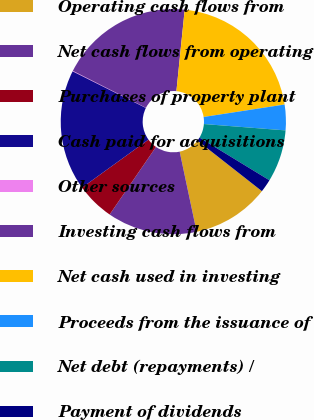Convert chart to OTSL. <chart><loc_0><loc_0><loc_500><loc_500><pie_chart><fcel>Operating cash flows from<fcel>Net cash flows from operating<fcel>Purchases of property plant<fcel>Cash paid for acquisitions<fcel>Other sources<fcel>Investing cash flows from<fcel>Net cash used in investing<fcel>Proceeds from the issuance of<fcel>Net debt (repayments) /<fcel>Payment of dividends<nl><fcel>11.09%<fcel>12.89%<fcel>5.47%<fcel>17.35%<fcel>0.07%<fcel>19.16%<fcel>20.96%<fcel>3.67%<fcel>7.48%<fcel>1.87%<nl></chart> 